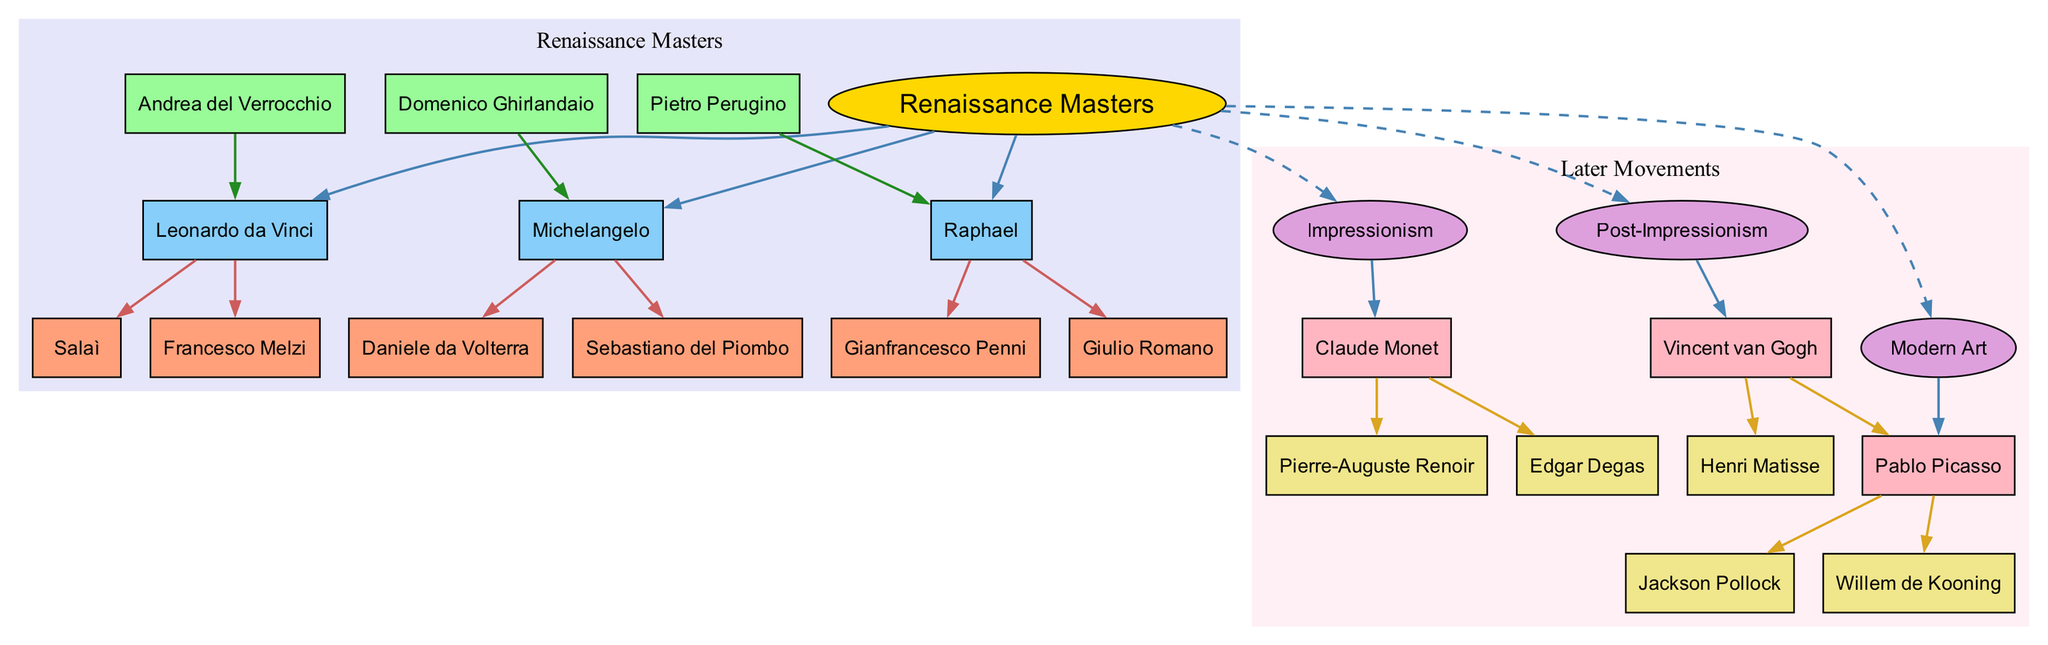What is the root of the family tree? The root node is labeled "Renaissance Masters", which signifies the main starting point of the diagram capturing the legacy of important artists and their relationships.
Answer: Renaissance Masters Who mentored Leonardo da Vinci? The diagram shows that Leonardo da Vinci is connected to Andrea del Verrocchio by an edge indicating that he was the mentor of Leonardo.
Answer: Andrea del Verrocchio How many protégés did Michelangelo have? By examining the edges connected to Michelangelo, we can see that there are two names listed as protégés: Sebastiano del Piombo and Daniele da Volterra. Counting these gives us 2.
Answer: 2 Which artistic movement is associated with Claude Monet? The diagram indicates that Claude Monet is the key figure in the "Impressionism" offshoot, as there is an edge drawing a connection from the "Impressionism" node to Monet.
Answer: Impressionism Name one painter influenced by Vincent van Gogh. The diagram shows that Vincent van Gogh influenced Henri Matisse and Pablo Picasso; either name is correct as both are connected beneath his name.
Answer: Henri Matisse What is the relationship between Raphael and Pietro Perugino? The diagram illustrates a mentorship relationship where Pietro Perugino is linked to Raphael as his mentor, indicated by a directed edge from Perugino to Raphael.
Answer: Mentor Which artist is noted as a key figure in Modern Art? Looking at the Modern Art offshoot within the diagram, Pablo Picasso is identified as the key figure listed directly under that movement.
Answer: Pablo Picasso How many branches are under Renaissance Masters? The diagram lists three specific branches below "Renaissance Masters" - Leonardo da Vinci, Michelangelo, and Raphael, leading us to a count of 3 branches.
Answer: 3 Which protégé is connected to Leonardo da Vinci? Examining the connections of Leonardo, we see direct edges leading to two protégés: Francesco Melzi and Salaì. Hence, either of these names could be the answer.
Answer: Francesco Melzi 